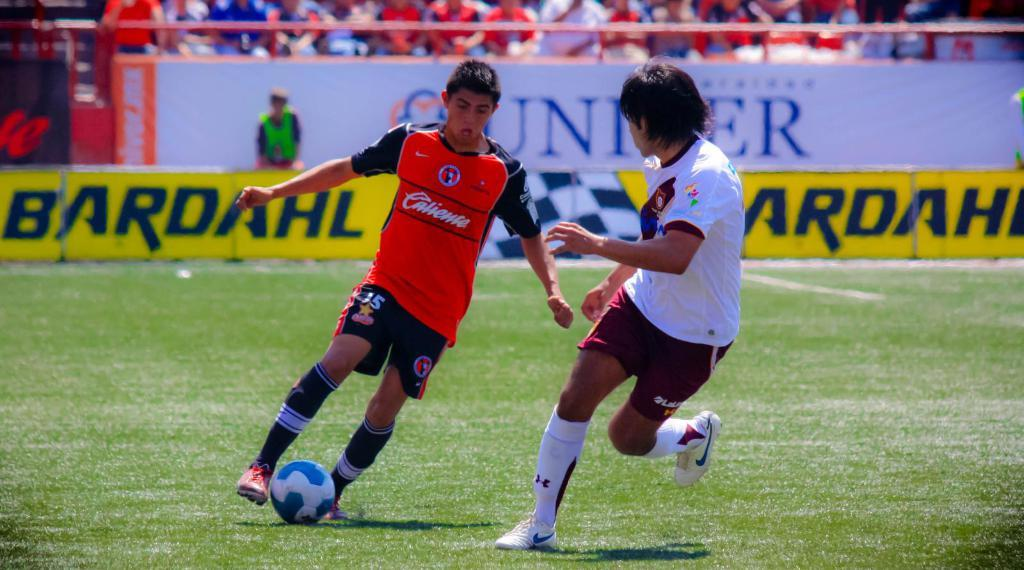What is the setting of the image? The image shows an outside view. What activity are the two persons engaged in? They are playing football. What object is located in the middle of the image? There is a board in the middle of the image. Can you describe the presence of other people in the image? There is a crowd visible at the top of the image. How many fish can be seen swimming in the image? There are no fish visible in the image; it shows an outdoor scene with people playing football. Is there a spy observing the football game in the image? There is no indication of a spy or any secretive activity in the image. 